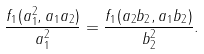Convert formula to latex. <formula><loc_0><loc_0><loc_500><loc_500>\frac { f _ { 1 } ( a _ { 1 } ^ { 2 } , a _ { 1 } a _ { 2 } ) } { a _ { 1 } ^ { 2 } } = \frac { f _ { 1 } ( a _ { 2 } b _ { 2 } , a _ { 1 } b _ { 2 } ) } { b _ { 2 } ^ { 2 } } .</formula> 